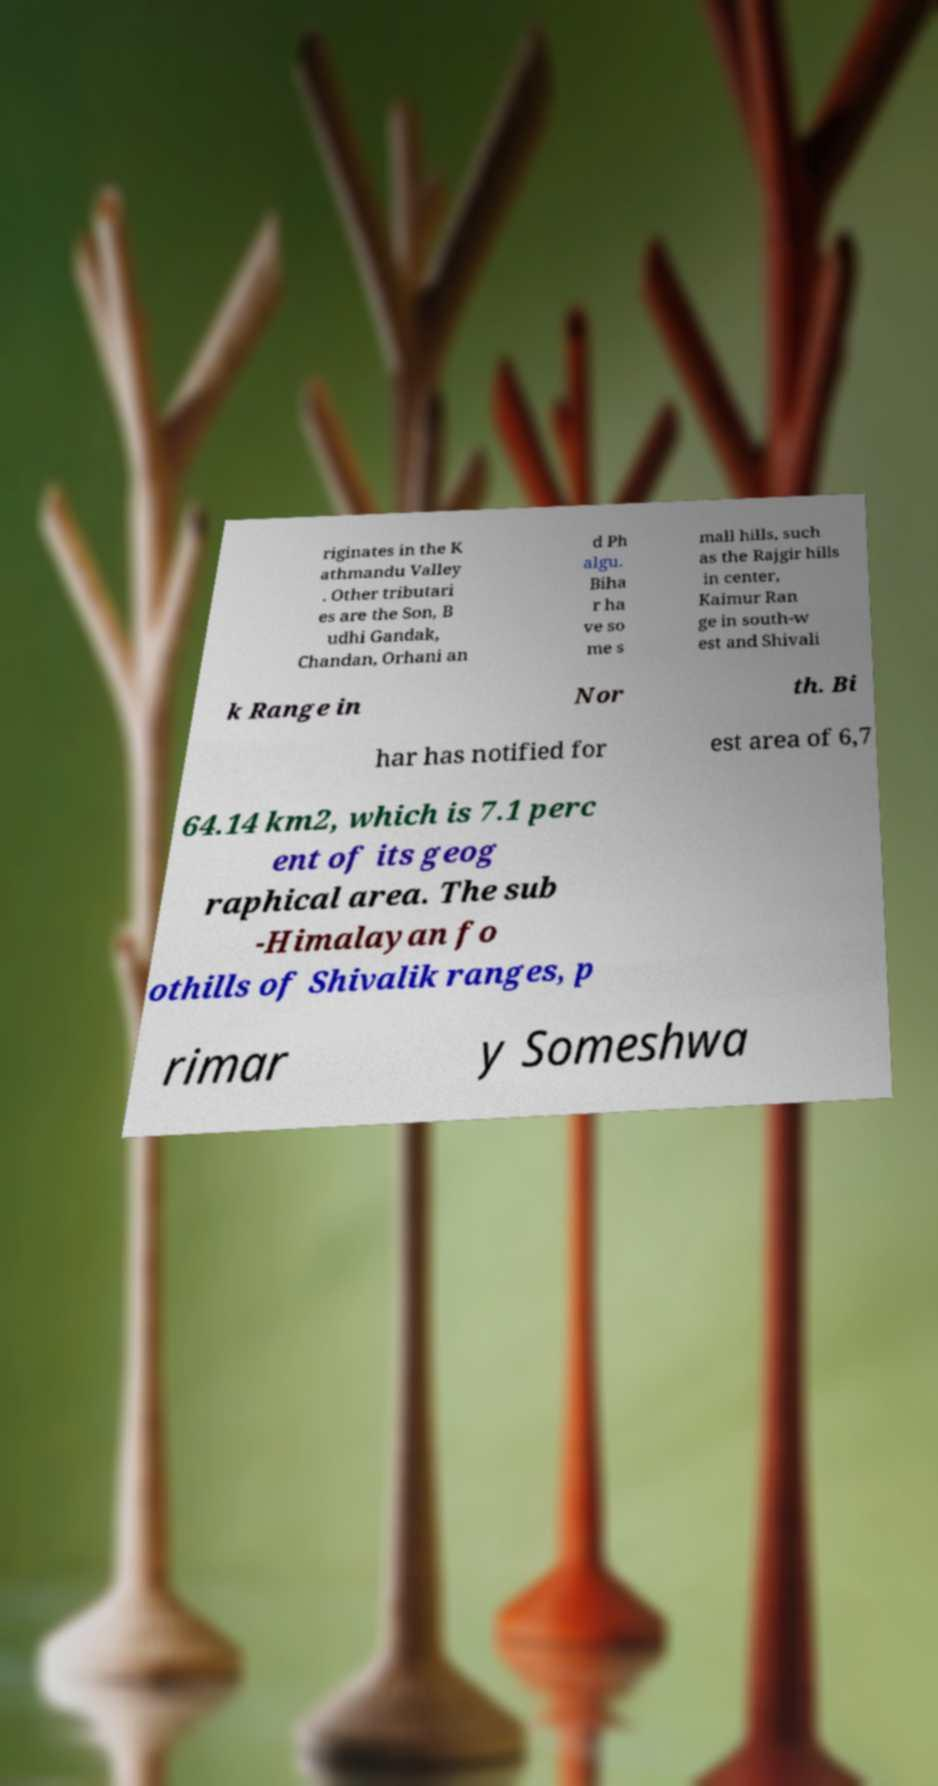Could you extract and type out the text from this image? riginates in the K athmandu Valley . Other tributari es are the Son, B udhi Gandak, Chandan, Orhani an d Ph algu. Biha r ha ve so me s mall hills, such as the Rajgir hills in center, Kaimur Ran ge in south-w est and Shivali k Range in Nor th. Bi har has notified for est area of 6,7 64.14 km2, which is 7.1 perc ent of its geog raphical area. The sub -Himalayan fo othills of Shivalik ranges, p rimar y Someshwa 